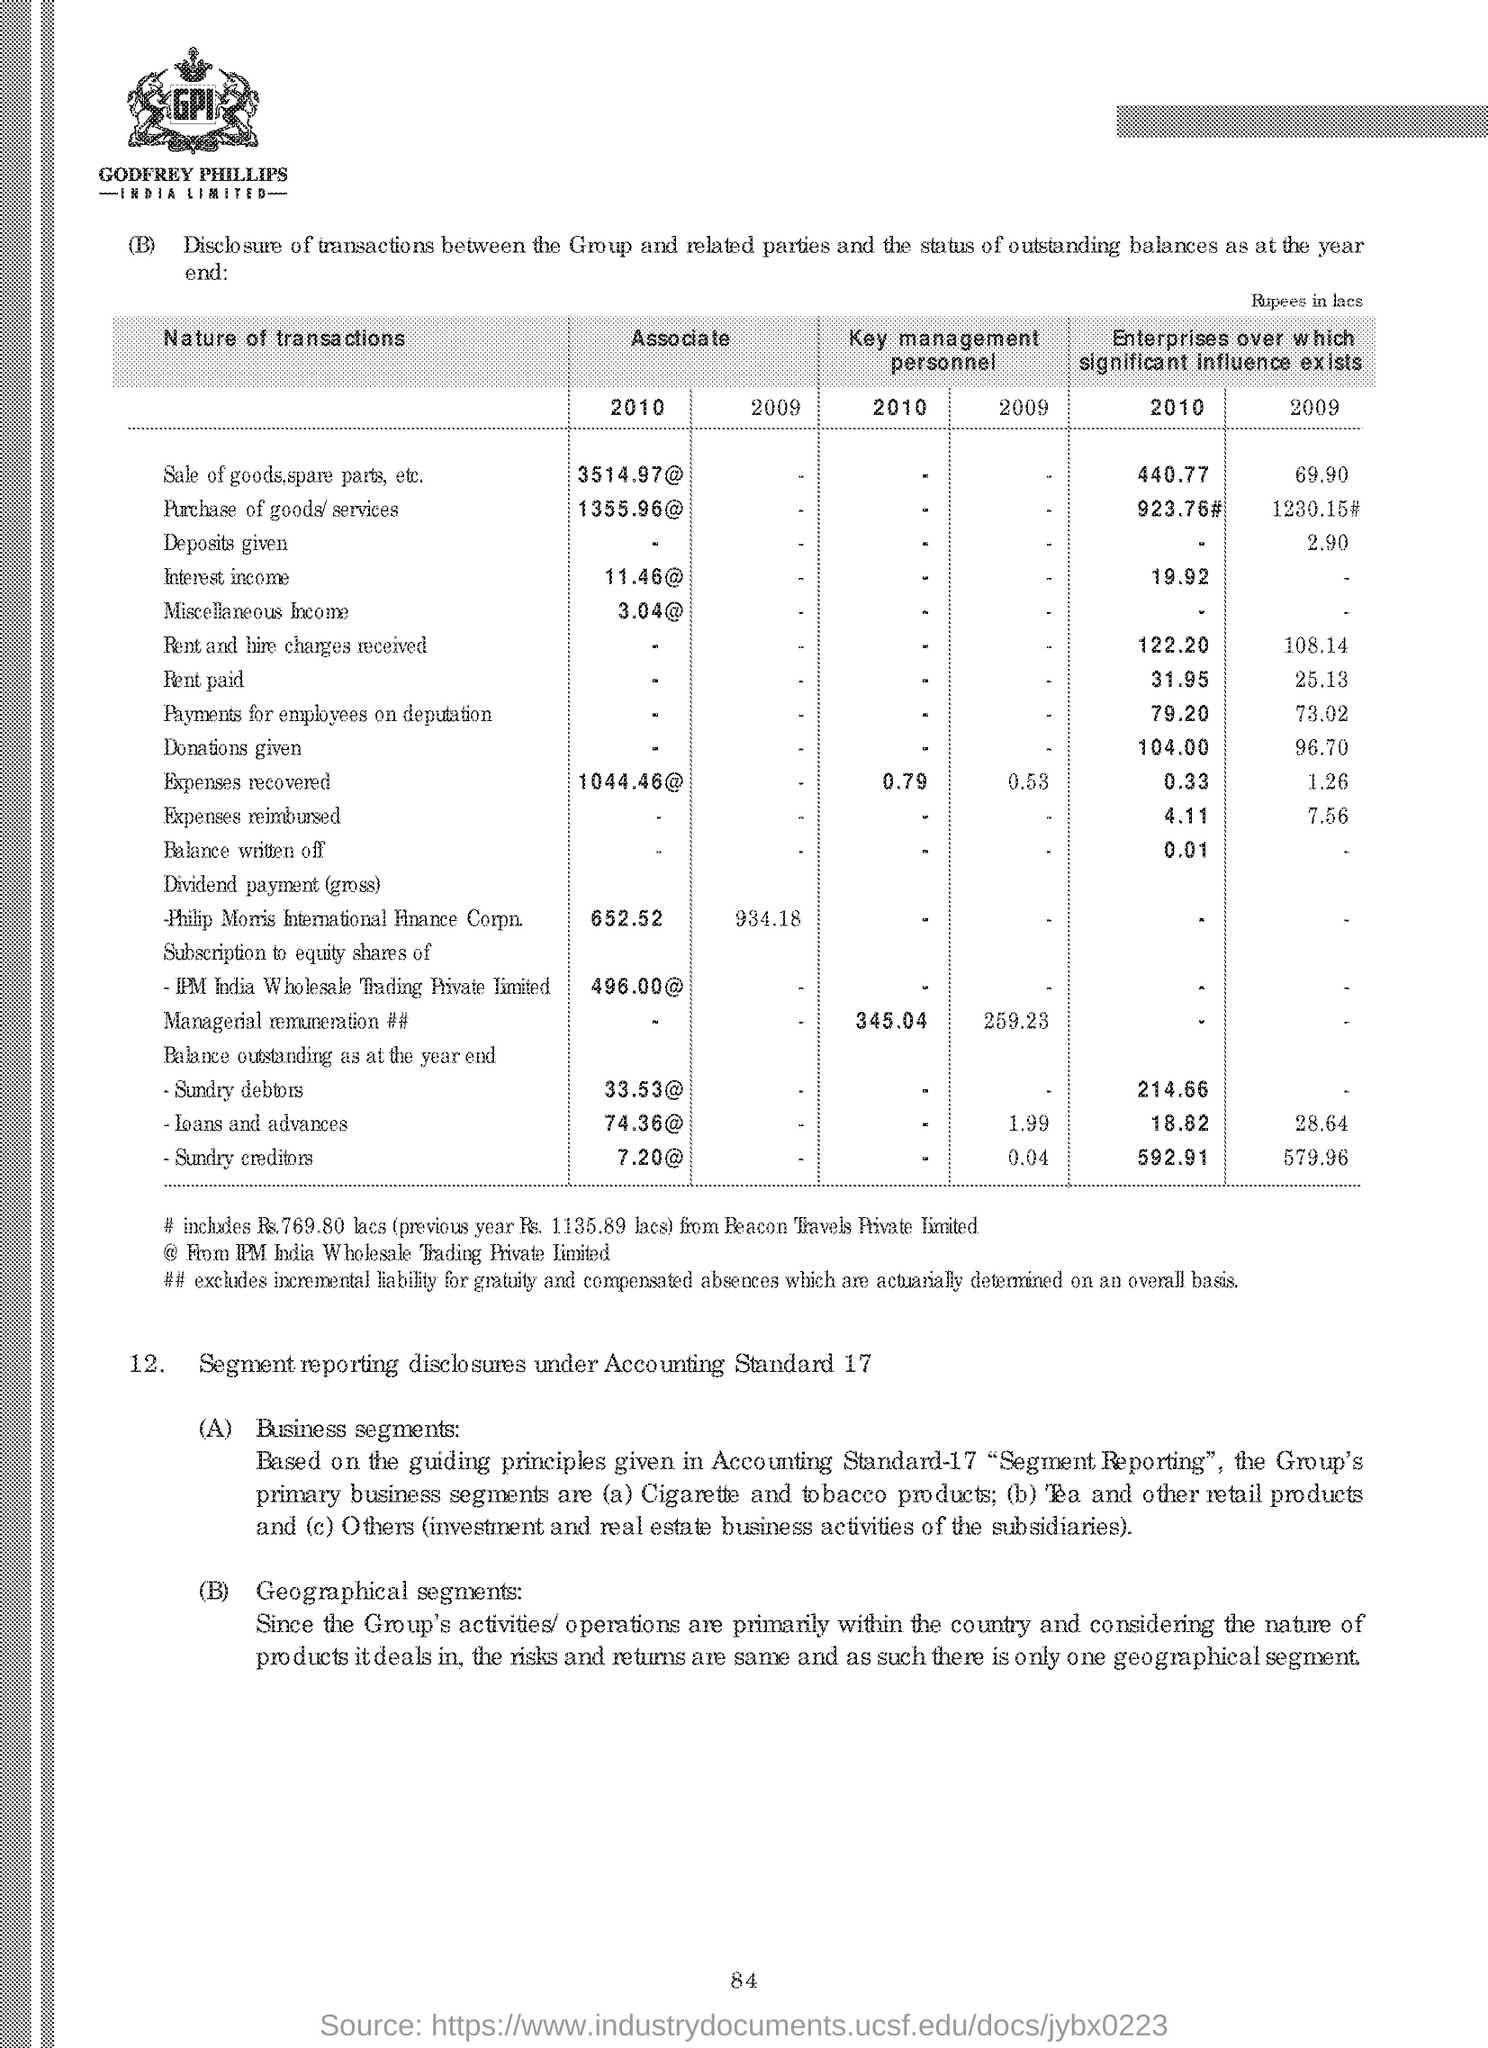What is the symbol @ denotes ?
Provide a succinct answer. From IPM India Wholesale Trading Private Limited. What is the first transaction in the table ?
Offer a very short reply. Sale of goods, spare parts, etc. In which year transaction 'Sale of goods, spare parts, etc' have more significant influences over enterprises?
Make the answer very short. 2010. What is the Associate value for the year '2010' for transaction 'Purchase of goods/services'
Provide a succinct answer. 1355.96@. 